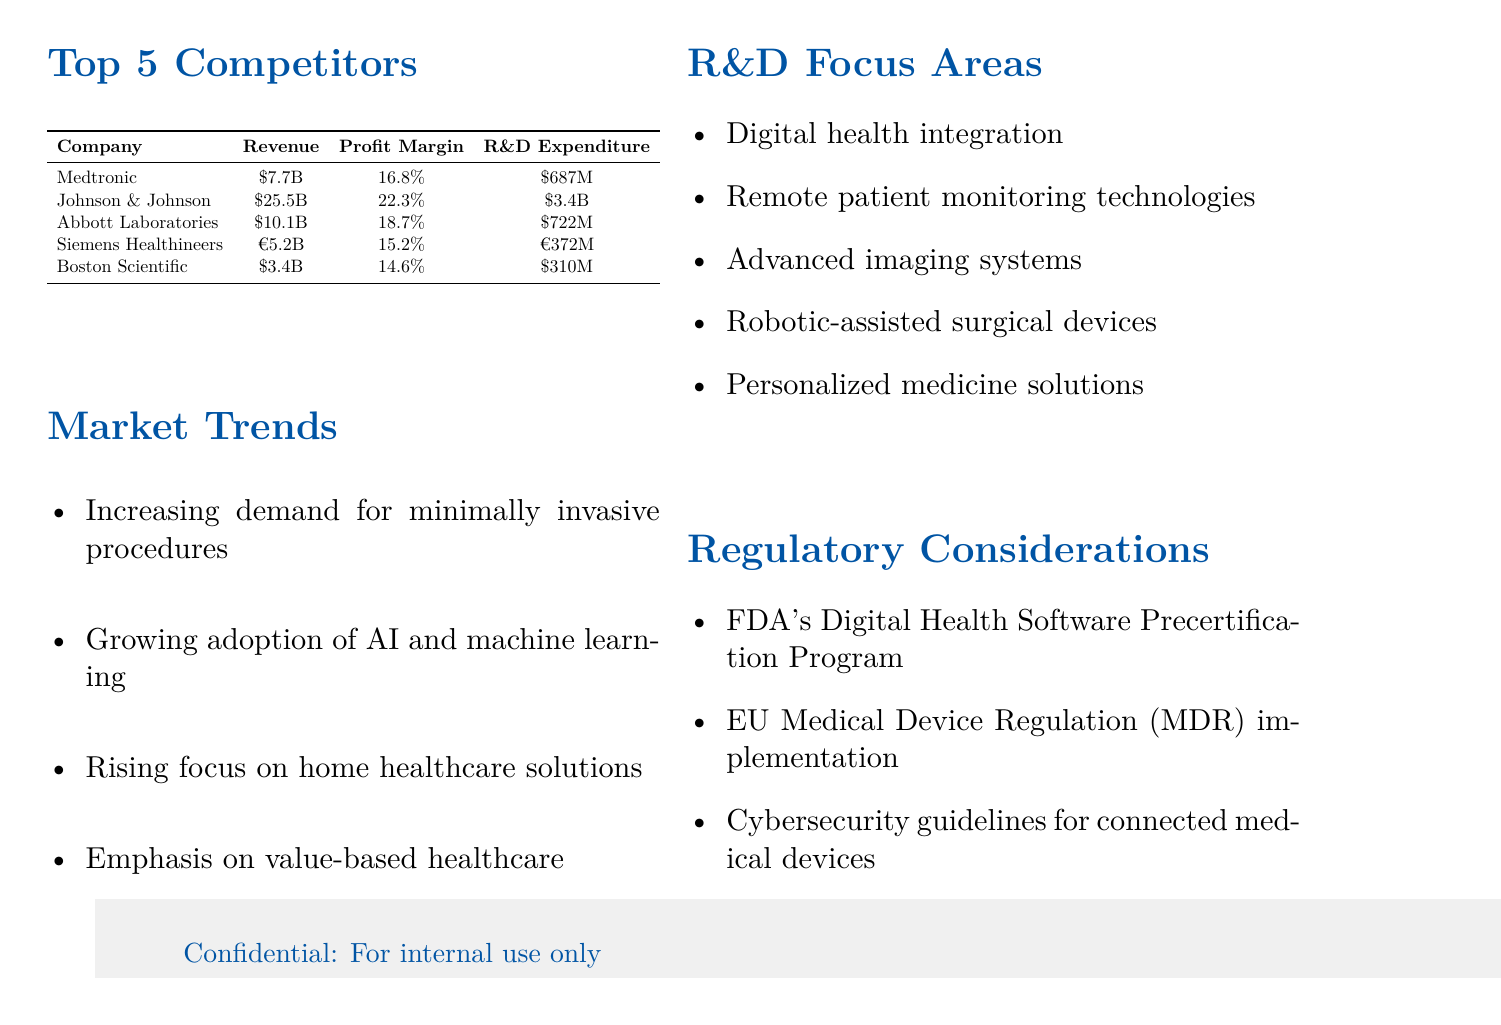What is the profit margin for Johnson & Johnson? The profit margin for Johnson & Johnson is listed under the profit margin section for that company in the document.
Answer: 22.3% What is the revenue of Boston Scientific? The revenue for Boston Scientific is provided in the financial data table within the document.
Answer: $3.4 billion Which company has the highest R&D expenditure? R&D expenditures for all companies are detailed in the financial data table, allowing for comparison to determine the highest expenditure.
Answer: Johnson & Johnson What is the primary trend in the medical device market? The document lists market trends that are currently influential in the medical device industry, and these trends are outlined in a bullet list.
Answer: Increasing demand for minimally invasive procedures What is Siemens Healthineers' R&D expenditure in euros? Siemens Healthineers' R&D expenditure is stated in euros in the financial data section of the document.
Answer: €372 million Which competitor has the lowest profit margin? The profit margins are presented in the financial table, enabling identification of the lowest margin by comparing values.
Answer: Boston Scientific What are the focus areas for R&D highlighted in the document? The document includes specific focus areas for R&D in a bullet list, summarizing what competitors are concentrating on.
Answer: Digital health integration What regulatory consideration is mentioned in the report? The document contains several regulatory considerations listed that are pertinent to the medical device industry.
Answer: FDA's Digital Health Software Precertification Program 